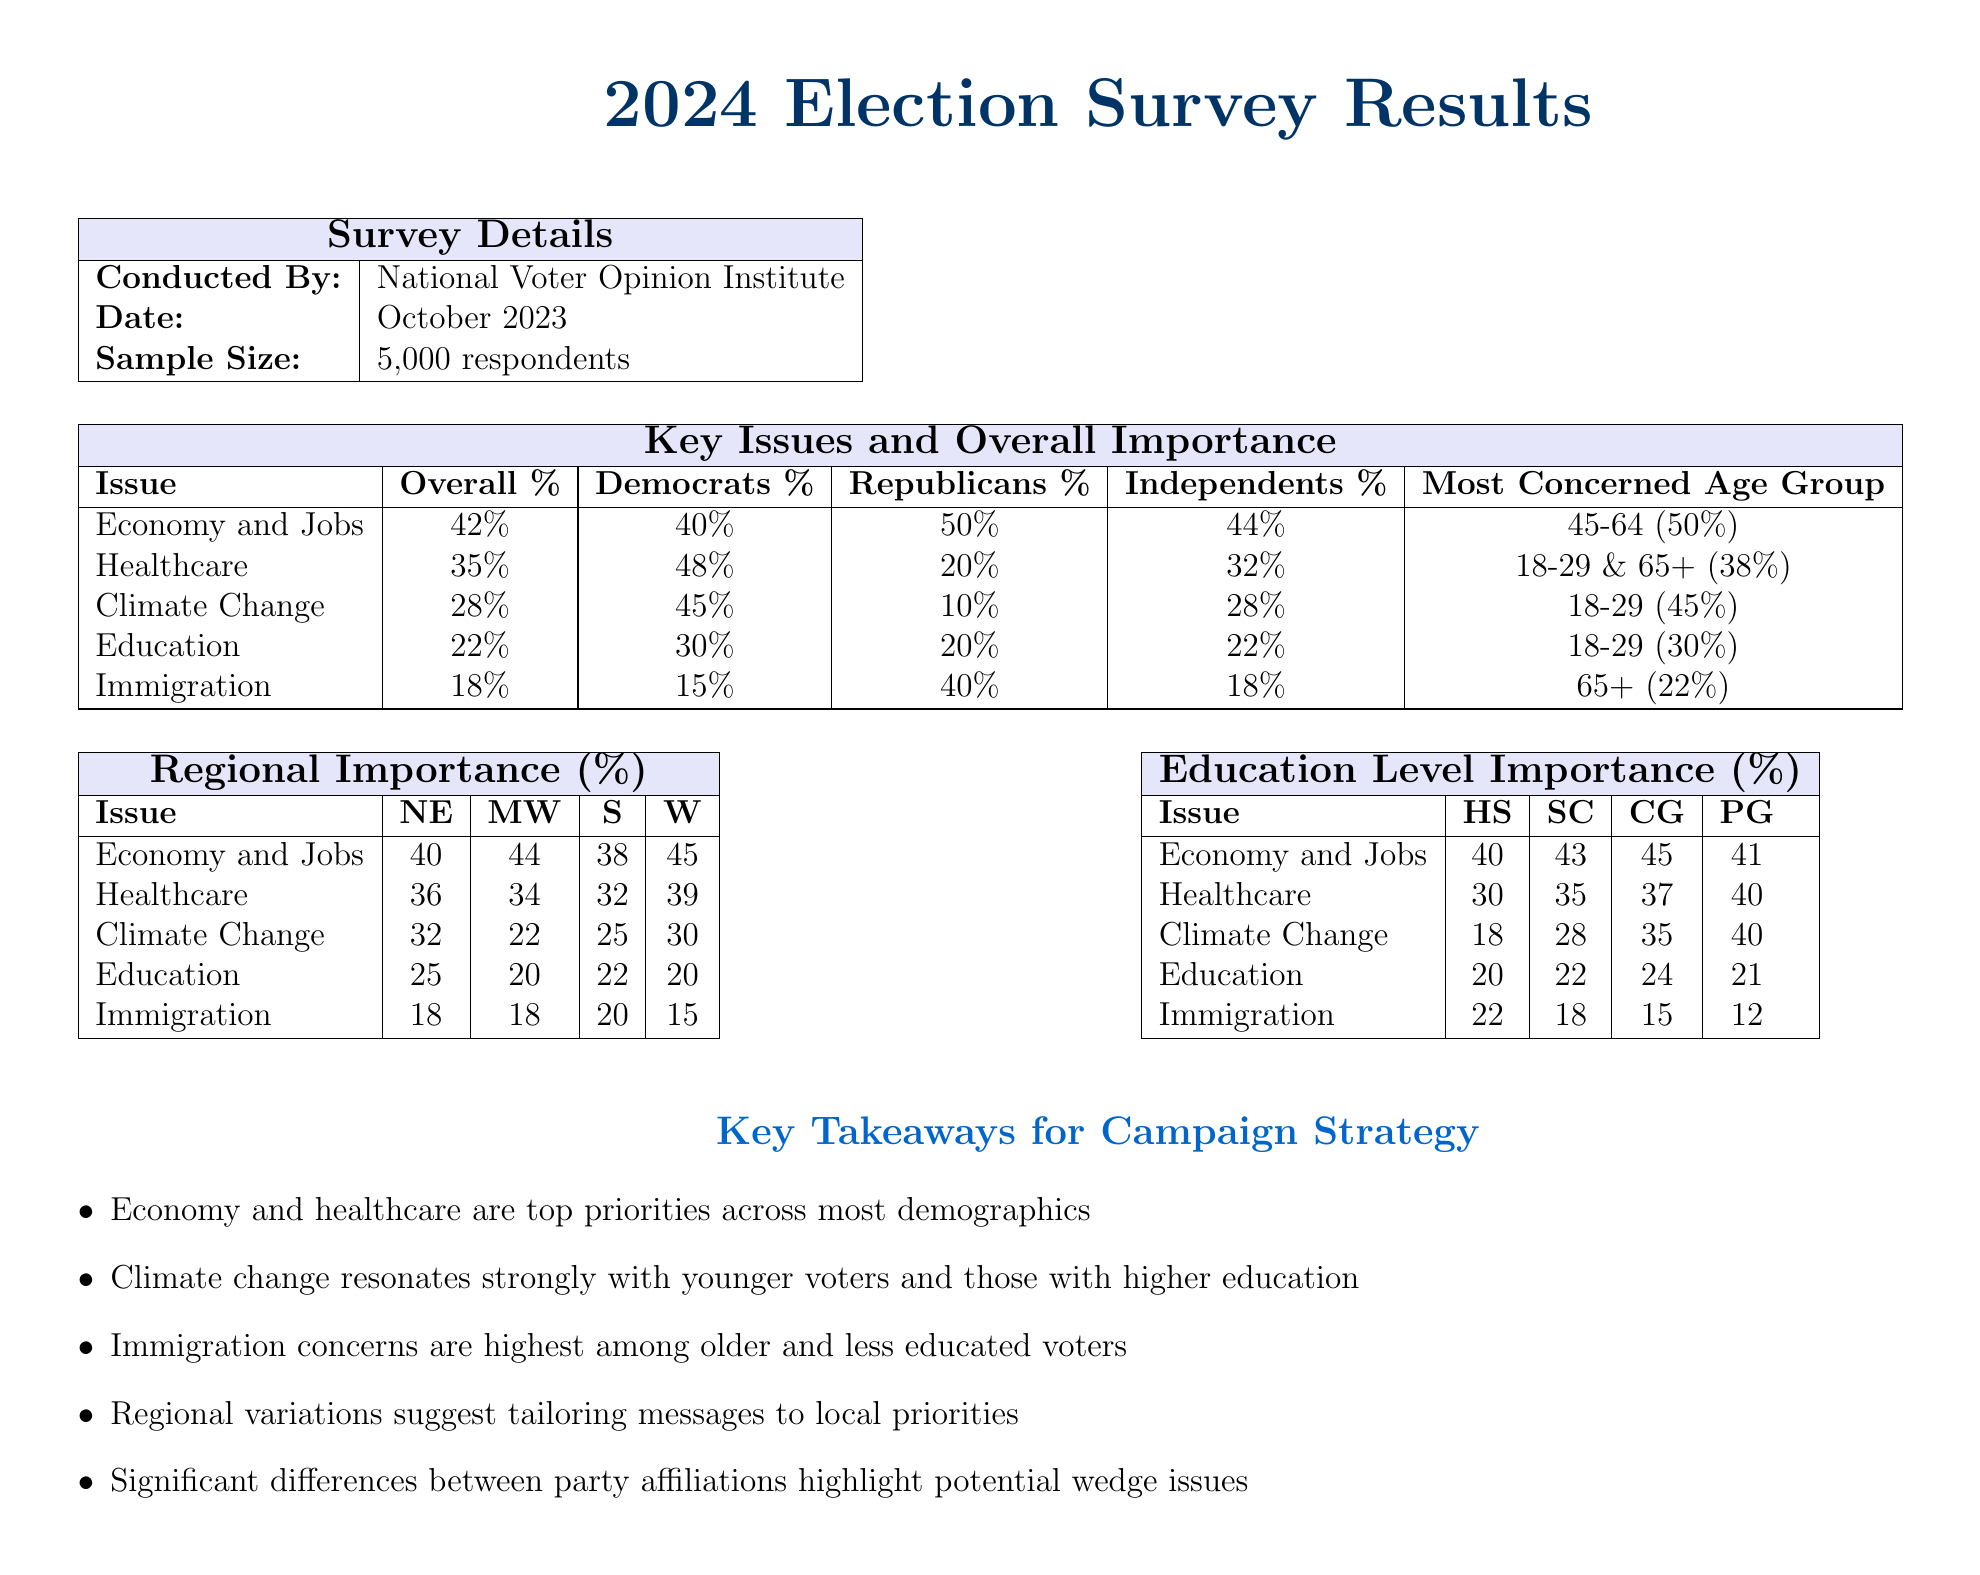What organization conducted the survey? The organization that conducted the survey is mentioned in the document under "Survey Details."
Answer: National Voter Opinion Institute What was the sample size of the respondents? The sample size is specified in the "Survey Details" section of the document.
Answer: 5,000 respondents Which age group is most concerned about the economy and jobs? The document indicates the most concerned age group for each issue in the "Key Issues and Overall Importance" table.
Answer: 45-64 (50%) What percentage of Democrats prioritize healthcare? The percentage of Democrats concerned about healthcare can be found in the "Key Issues and Overall Importance" table.
Answer: 48% Which region has the highest importance for climate change? The regional importance is detailed in the "Regional Importance (%)" table, indicating the highest percentage.
Answer: NE (32) How does the concern for immigration vary by education level? The "Education Level Importance (%)" table provides the percentages, revealing the variation in importance.
Answer: HS (22) Which key issue resonates most with younger voters? The document highlights the most concerned issues for younger voters in the "Key Issues and Overall Importance" section.
Answer: Climate Change Name one takeaway for campaign strategy highlighted in the document. Key takeaways for campaign strategy are listed in a dedicated section at the end of the document.
Answer: Economy and healthcare are top priorities across most demographics 